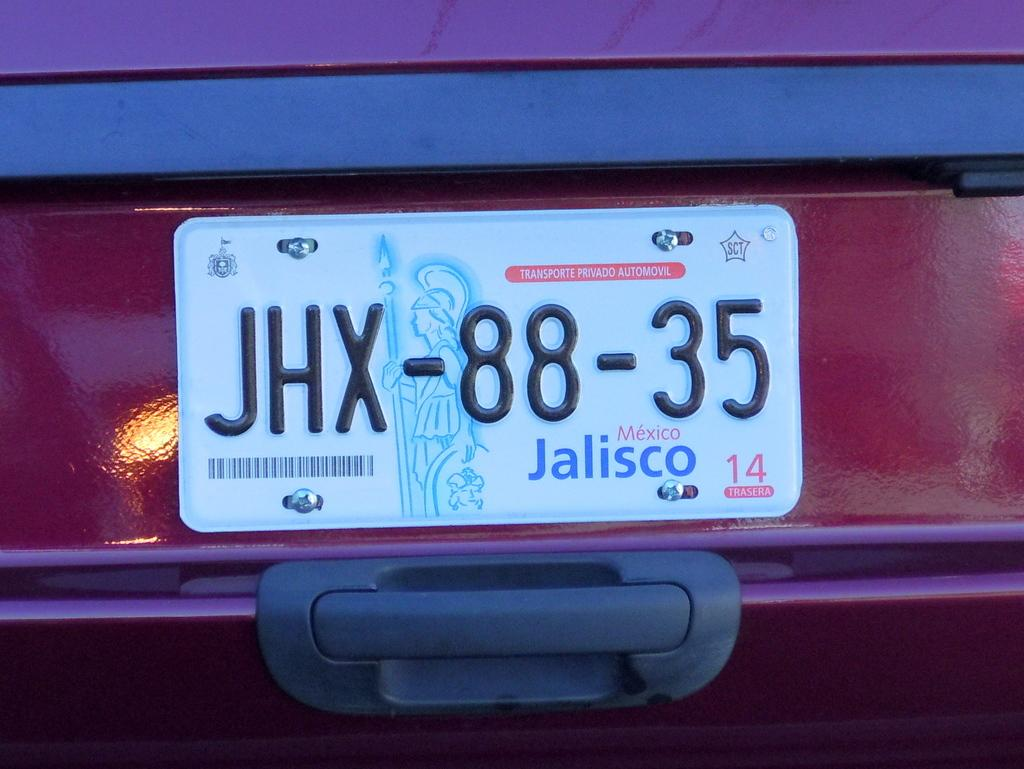<image>
Give a short and clear explanation of the subsequent image. A Mexican number plate reading JHx-88-35 is on a red car 